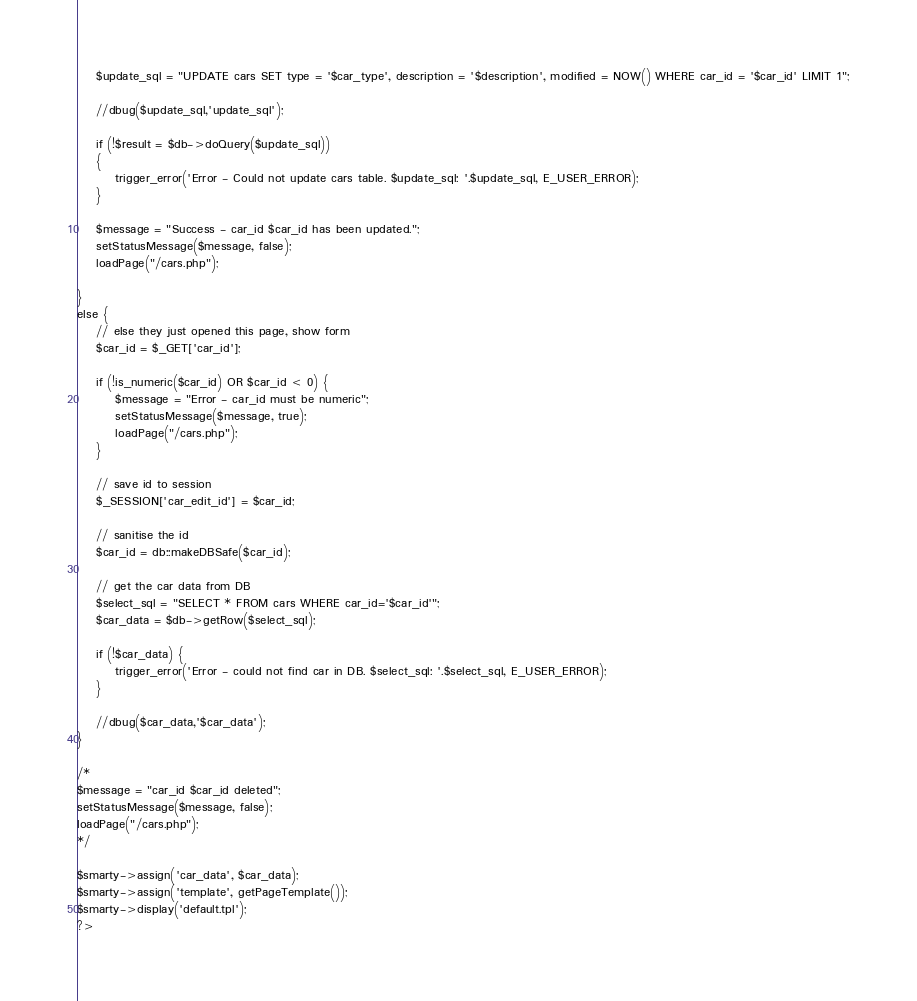Convert code to text. <code><loc_0><loc_0><loc_500><loc_500><_PHP_>	$update_sql = "UPDATE cars SET type = '$car_type', description = '$description', modified = NOW() WHERE car_id = '$car_id' LIMIT 1";
	
	//dbug($update_sql,'update_sql');

	if (!$result = $db->doQuery($update_sql))
	{
		trigger_error('Error - Could not update cars table. $update_sql: '.$update_sql, E_USER_ERROR);
	}
	
	$message = "Success - car_id $car_id has been updated.";
	setStatusMessage($message, false);
	loadPage("/cars.php");
	
}
else {
	// else they just opened this page, show form
	$car_id = $_GET['car_id'];

	if (!is_numeric($car_id) OR $car_id < 0) {
		$message = "Error - car_id must be numeric";
		setStatusMessage($message, true);
		loadPage("/cars.php");
	}
	
	// save id to session
	$_SESSION['car_edit_id'] = $car_id;
	
	// sanitise the id
	$car_id = db::makeDBSafe($car_id);
	
	// get the car data from DB
	$select_sql = "SELECT * FROM cars WHERE car_id='$car_id'";
	$car_data = $db->getRow($select_sql);
	
	if (!$car_data) {
		trigger_error('Error - could not find car in DB. $select_sql: '.$select_sql, E_USER_ERROR);
	}
	
	//dbug($car_data,'$car_data');
}
	
/*	
$message = "car_id $car_id deleted";
setStatusMessage($message, false);
loadPage("/cars.php");
*/

$smarty->assign('car_data', $car_data);
$smarty->assign('template', getPageTemplate());
$smarty->display('default.tpl');
?></code> 